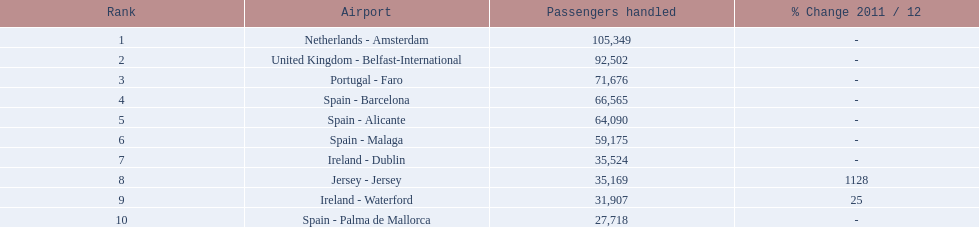What are the 10 most hectic routes to and from london southend airport? Netherlands - Amsterdam, United Kingdom - Belfast-International, Portugal - Faro, Spain - Barcelona, Spain - Alicante, Spain - Malaga, Ireland - Dublin, Jersey - Jersey, Ireland - Waterford, Spain - Palma de Mallorca. Of these, which airport is situated in portugal? Portugal - Faro. 